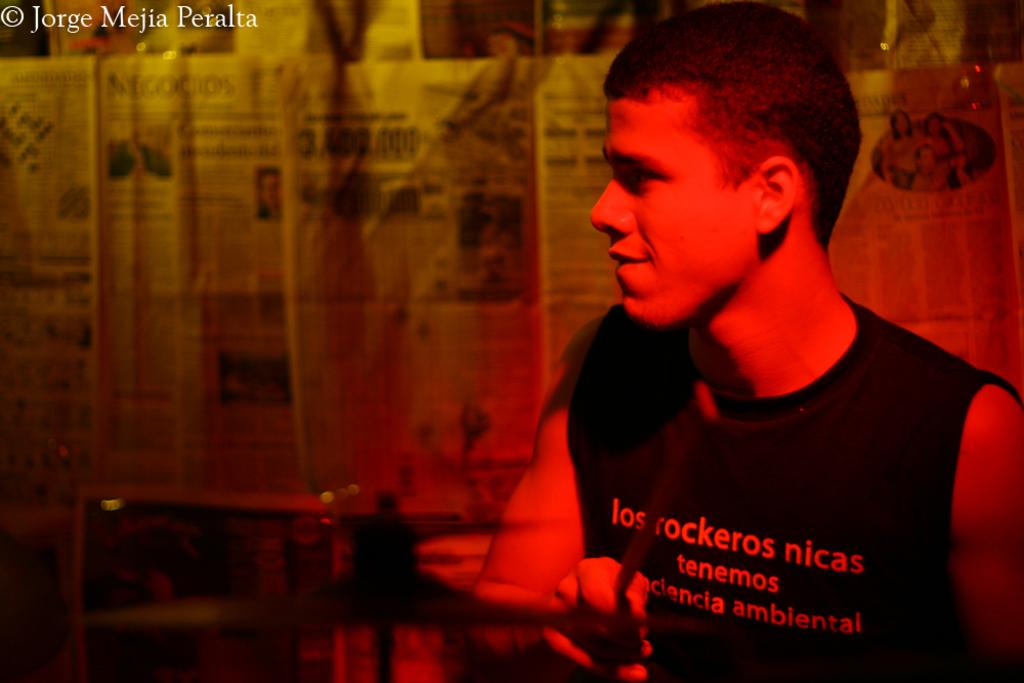What is the person in the image doing? The person is playing a musical instrument in the image. What can be seen in the background of the image? There is paper visible in the background of the image. Can you describe the text at the top of the image? Unfortunately, the provided facts do not give any information about the text at the top of the image. How does the person in the image provide comfort to the end of the friction? There is no reference to comfort, end, or friction in the image. The image only shows a person playing a musical instrument and paper in the background. 